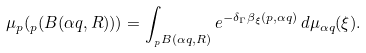<formula> <loc_0><loc_0><loc_500><loc_500>\mu _ { p } ( _ { p } ( B ( \alpha q , R ) ) ) = \int _ { _ { p } B ( \alpha q , R ) } e ^ { - \delta _ { \Gamma } \beta _ { \xi } ( p , \alpha q ) } \, d \mu _ { \alpha q } ( \xi ) .</formula> 